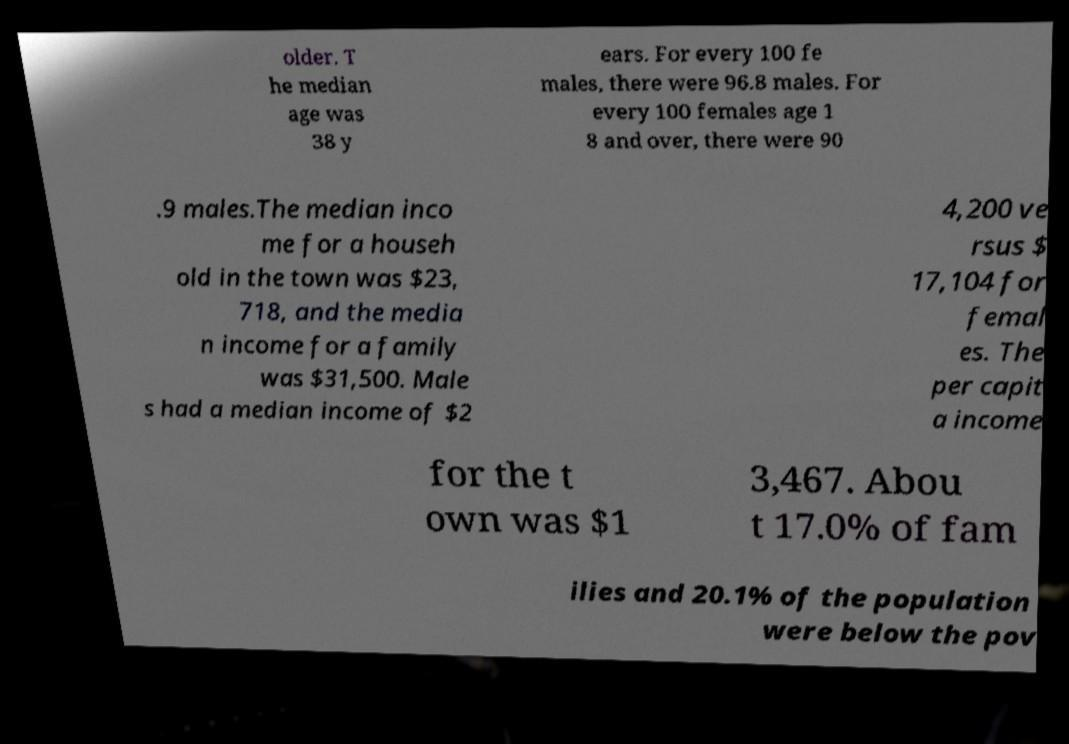What messages or text are displayed in this image? I need them in a readable, typed format. older. T he median age was 38 y ears. For every 100 fe males, there were 96.8 males. For every 100 females age 1 8 and over, there were 90 .9 males.The median inco me for a househ old in the town was $23, 718, and the media n income for a family was $31,500. Male s had a median income of $2 4,200 ve rsus $ 17,104 for femal es. The per capit a income for the t own was $1 3,467. Abou t 17.0% of fam ilies and 20.1% of the population were below the pov 